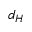Convert formula to latex. <formula><loc_0><loc_0><loc_500><loc_500>d _ { H }</formula> 